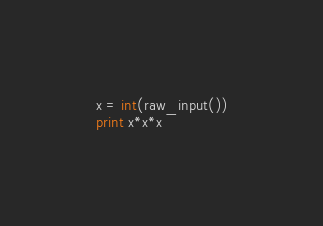Convert code to text. <code><loc_0><loc_0><loc_500><loc_500><_Python_>x = int(raw_input())
print x*x*x</code> 